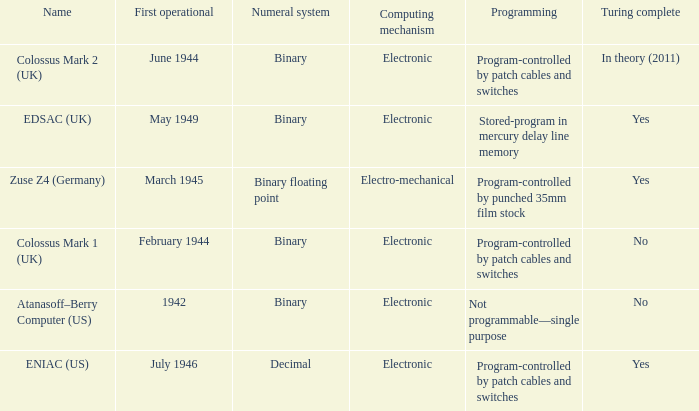What's the turing complete with name being atanasoff–berry computer (us) No. 